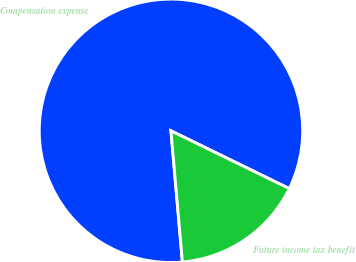Convert chart to OTSL. <chart><loc_0><loc_0><loc_500><loc_500><pie_chart><fcel>Compensation expense<fcel>Future income tax benefit<nl><fcel>83.62%<fcel>16.38%<nl></chart> 